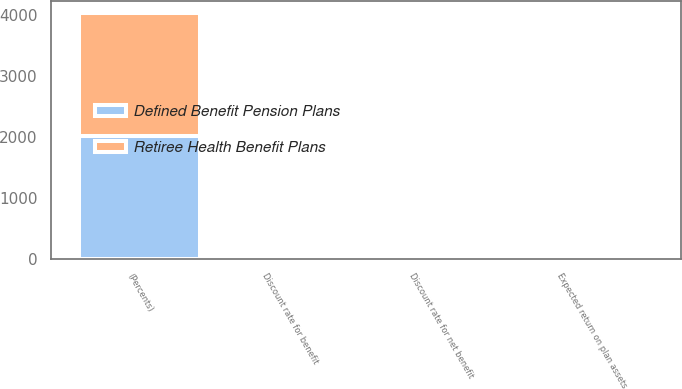<chart> <loc_0><loc_0><loc_500><loc_500><stacked_bar_chart><ecel><fcel>(Percents)<fcel>Discount rate for benefit<fcel>Discount rate for net benefit<fcel>Expected return on plan assets<nl><fcel>Retiree Health Benefit Plans<fcel>2018<fcel>3.9<fcel>3.4<fcel>7.3<nl><fcel>Defined Benefit Pension Plans<fcel>2018<fcel>4.4<fcel>3.7<fcel>8<nl></chart> 